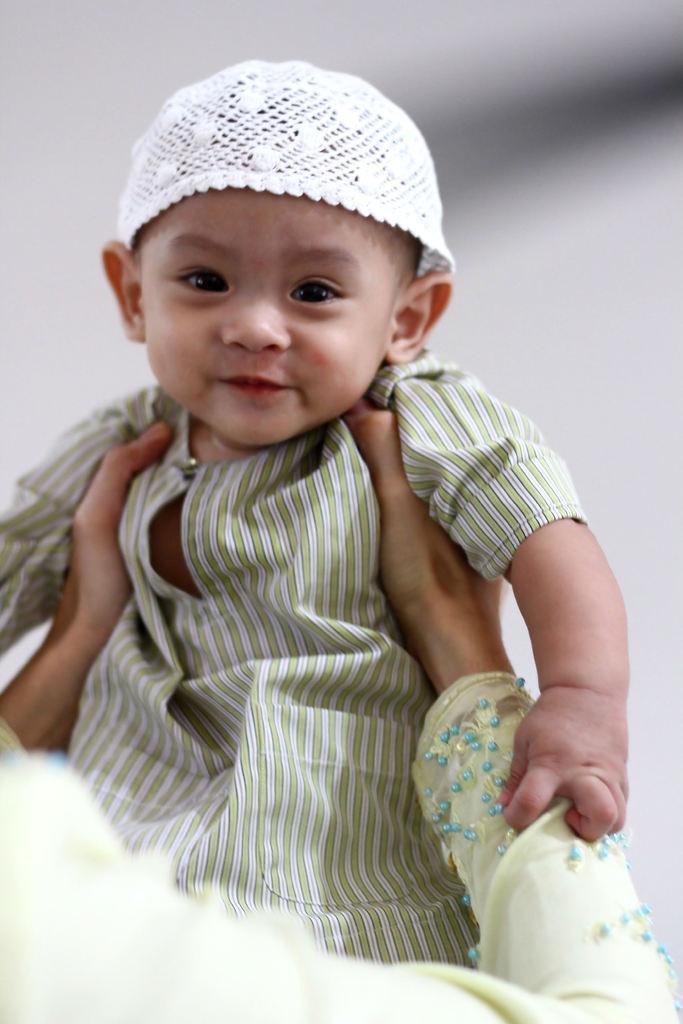Please provide a concise description of this image. In this image I can see a child wearing green and white colored dress and white colored hat. I can see a person is holding the child and I can see the blurry background. 